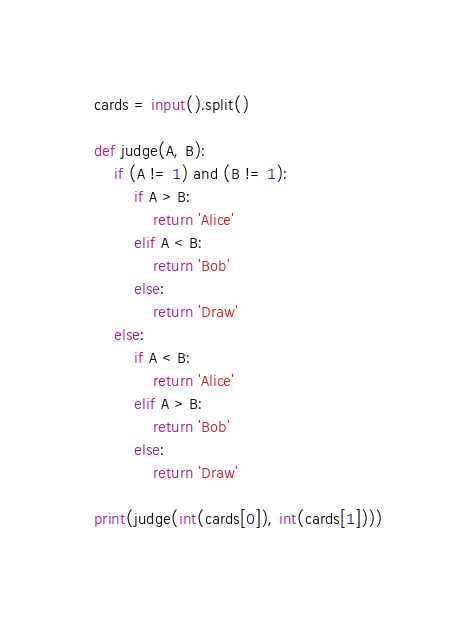Convert code to text. <code><loc_0><loc_0><loc_500><loc_500><_Python_>cards = input().split()

def judge(A, B):
    if (A != 1) and (B != 1):
        if A > B:
            return 'Alice'
        elif A < B:
            return 'Bob'
        else:
            return 'Draw'
    else:
        if A < B:
            return 'Alice'
        elif A > B:
            return 'Bob'
        else:
            return 'Draw'

print(judge(int(cards[0]), int(cards[1])))</code> 